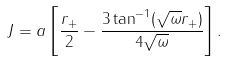Convert formula to latex. <formula><loc_0><loc_0><loc_500><loc_500>J = a \left [ \frac { r _ { + } } { 2 } - \frac { 3 \tan ^ { - 1 } ( \sqrt { \omega } r _ { + } ) } { 4 \sqrt { \omega } } \right ] .</formula> 